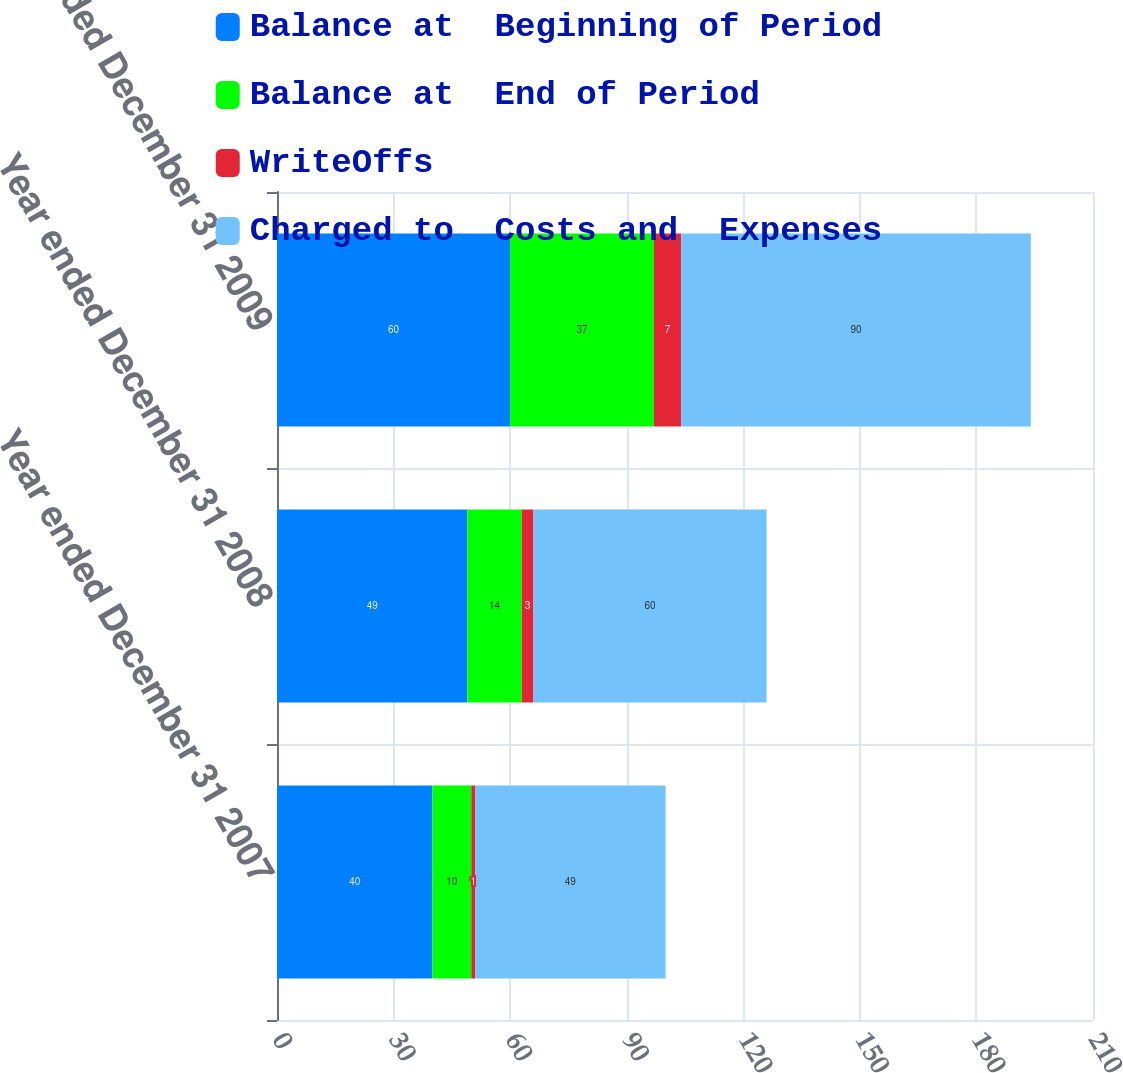Convert chart. <chart><loc_0><loc_0><loc_500><loc_500><stacked_bar_chart><ecel><fcel>Year ended December 31 2007<fcel>Year ended December 31 2008<fcel>Year ended December 31 2009<nl><fcel>Balance at  Beginning of Period<fcel>40<fcel>49<fcel>60<nl><fcel>Balance at  End of Period<fcel>10<fcel>14<fcel>37<nl><fcel>WriteOffs<fcel>1<fcel>3<fcel>7<nl><fcel>Charged to  Costs and  Expenses<fcel>49<fcel>60<fcel>90<nl></chart> 